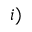Convert formula to latex. <formula><loc_0><loc_0><loc_500><loc_500>i )</formula> 